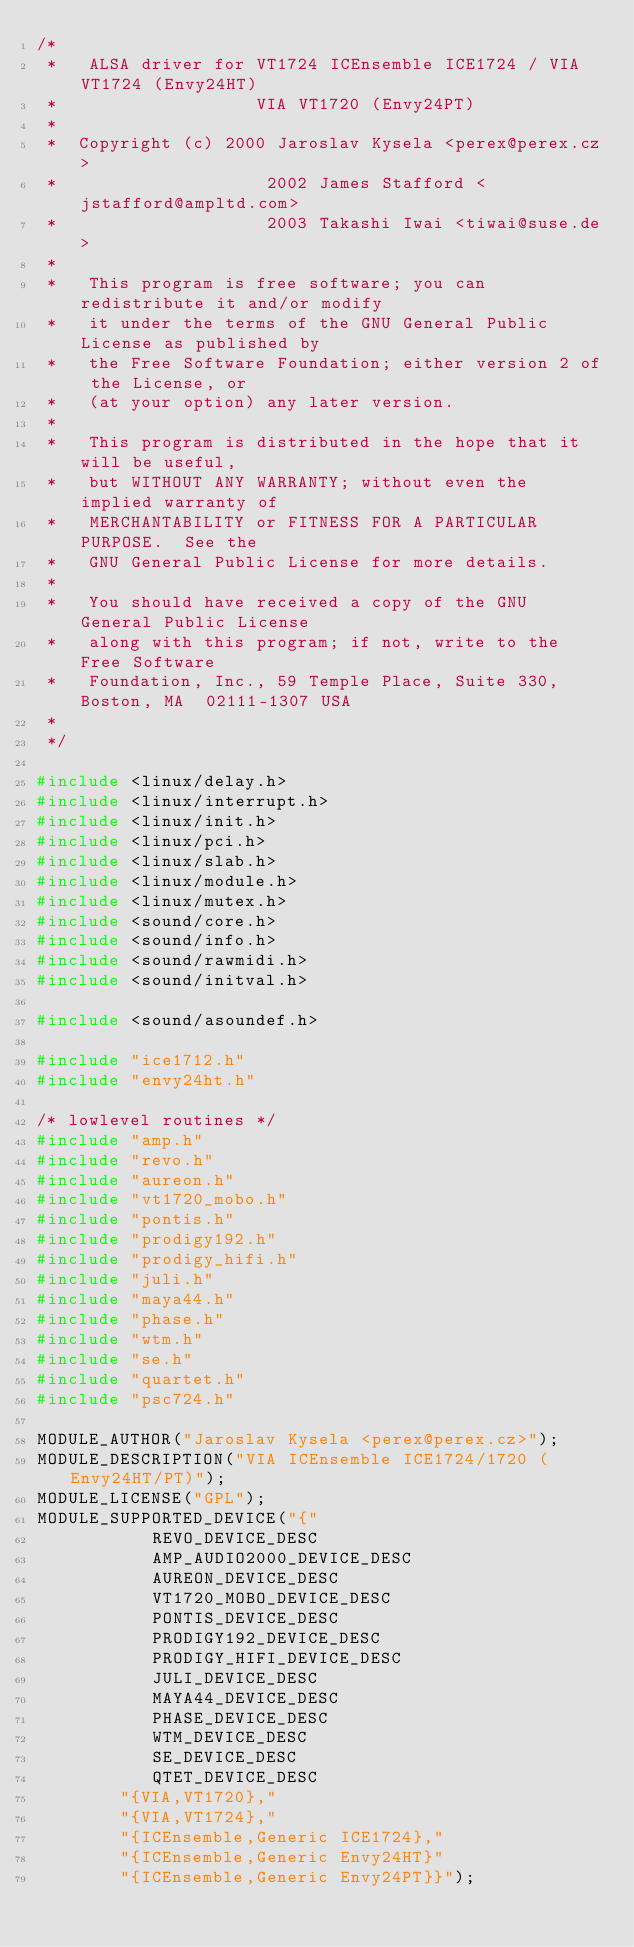Convert code to text. <code><loc_0><loc_0><loc_500><loc_500><_C_>/*
 *   ALSA driver for VT1724 ICEnsemble ICE1724 / VIA VT1724 (Envy24HT)
 *                   VIA VT1720 (Envy24PT)
 *
 *	Copyright (c) 2000 Jaroslav Kysela <perex@perex.cz>
 *                    2002 James Stafford <jstafford@ampltd.com>
 *                    2003 Takashi Iwai <tiwai@suse.de>
 *
 *   This program is free software; you can redistribute it and/or modify
 *   it under the terms of the GNU General Public License as published by
 *   the Free Software Foundation; either version 2 of the License, or
 *   (at your option) any later version.
 *
 *   This program is distributed in the hope that it will be useful,
 *   but WITHOUT ANY WARRANTY; without even the implied warranty of
 *   MERCHANTABILITY or FITNESS FOR A PARTICULAR PURPOSE.  See the
 *   GNU General Public License for more details.
 *
 *   You should have received a copy of the GNU General Public License
 *   along with this program; if not, write to the Free Software
 *   Foundation, Inc., 59 Temple Place, Suite 330, Boston, MA  02111-1307 USA
 *
 */

#include <linux/delay.h>
#include <linux/interrupt.h>
#include <linux/init.h>
#include <linux/pci.h>
#include <linux/slab.h>
#include <linux/module.h>
#include <linux/mutex.h>
#include <sound/core.h>
#include <sound/info.h>
#include <sound/rawmidi.h>
#include <sound/initval.h>

#include <sound/asoundef.h>

#include "ice1712.h"
#include "envy24ht.h"

/* lowlevel routines */
#include "amp.h"
#include "revo.h"
#include "aureon.h"
#include "vt1720_mobo.h"
#include "pontis.h"
#include "prodigy192.h"
#include "prodigy_hifi.h"
#include "juli.h"
#include "maya44.h"
#include "phase.h"
#include "wtm.h"
#include "se.h"
#include "quartet.h"
#include "psc724.h"

MODULE_AUTHOR("Jaroslav Kysela <perex@perex.cz>");
MODULE_DESCRIPTION("VIA ICEnsemble ICE1724/1720 (Envy24HT/PT)");
MODULE_LICENSE("GPL");
MODULE_SUPPORTED_DEVICE("{"
	       REVO_DEVICE_DESC
	       AMP_AUDIO2000_DEVICE_DESC
	       AUREON_DEVICE_DESC
	       VT1720_MOBO_DEVICE_DESC
	       PONTIS_DEVICE_DESC
	       PRODIGY192_DEVICE_DESC
	       PRODIGY_HIFI_DEVICE_DESC
	       JULI_DEVICE_DESC
	       MAYA44_DEVICE_DESC
	       PHASE_DEVICE_DESC
	       WTM_DEVICE_DESC
	       SE_DEVICE_DESC
	       QTET_DEVICE_DESC
		"{VIA,VT1720},"
		"{VIA,VT1724},"
		"{ICEnsemble,Generic ICE1724},"
		"{ICEnsemble,Generic Envy24HT}"
		"{ICEnsemble,Generic Envy24PT}}");
</code> 